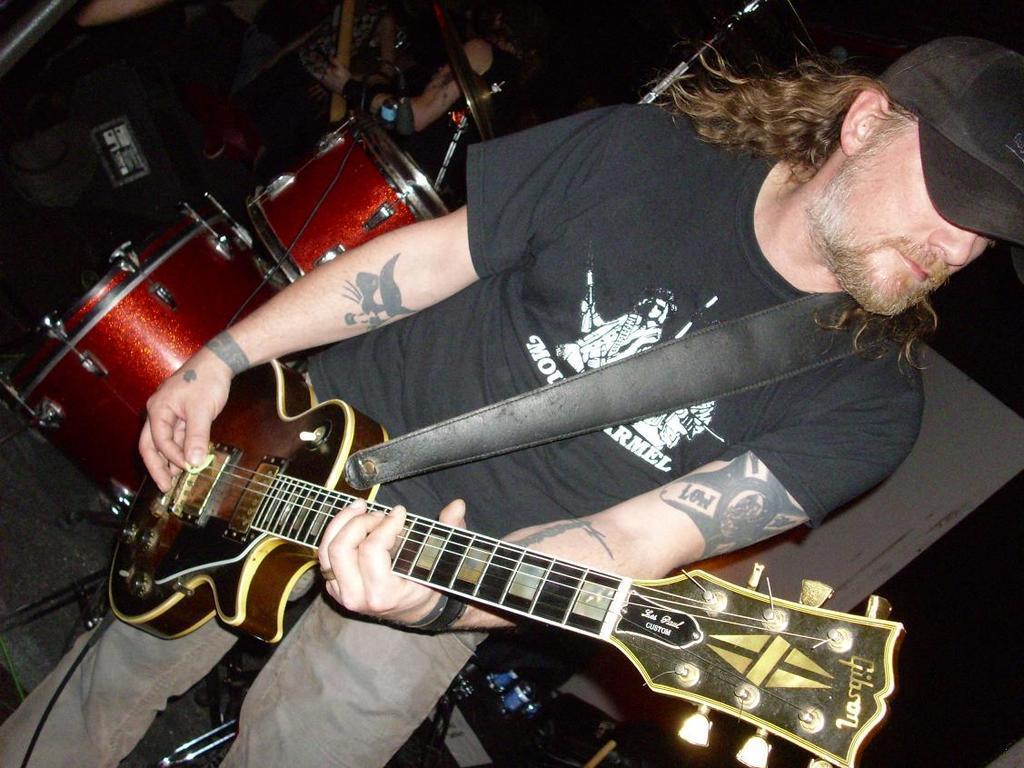Can you describe this image briefly? In this picture there is musician standing and playing guitar. The man is wearing a black T-shirt, jeans and cap. He has long hair. There is some text and image on his T-shirt. He has tattoos on his hands. Behind him there are drums. In the background there are some people. 